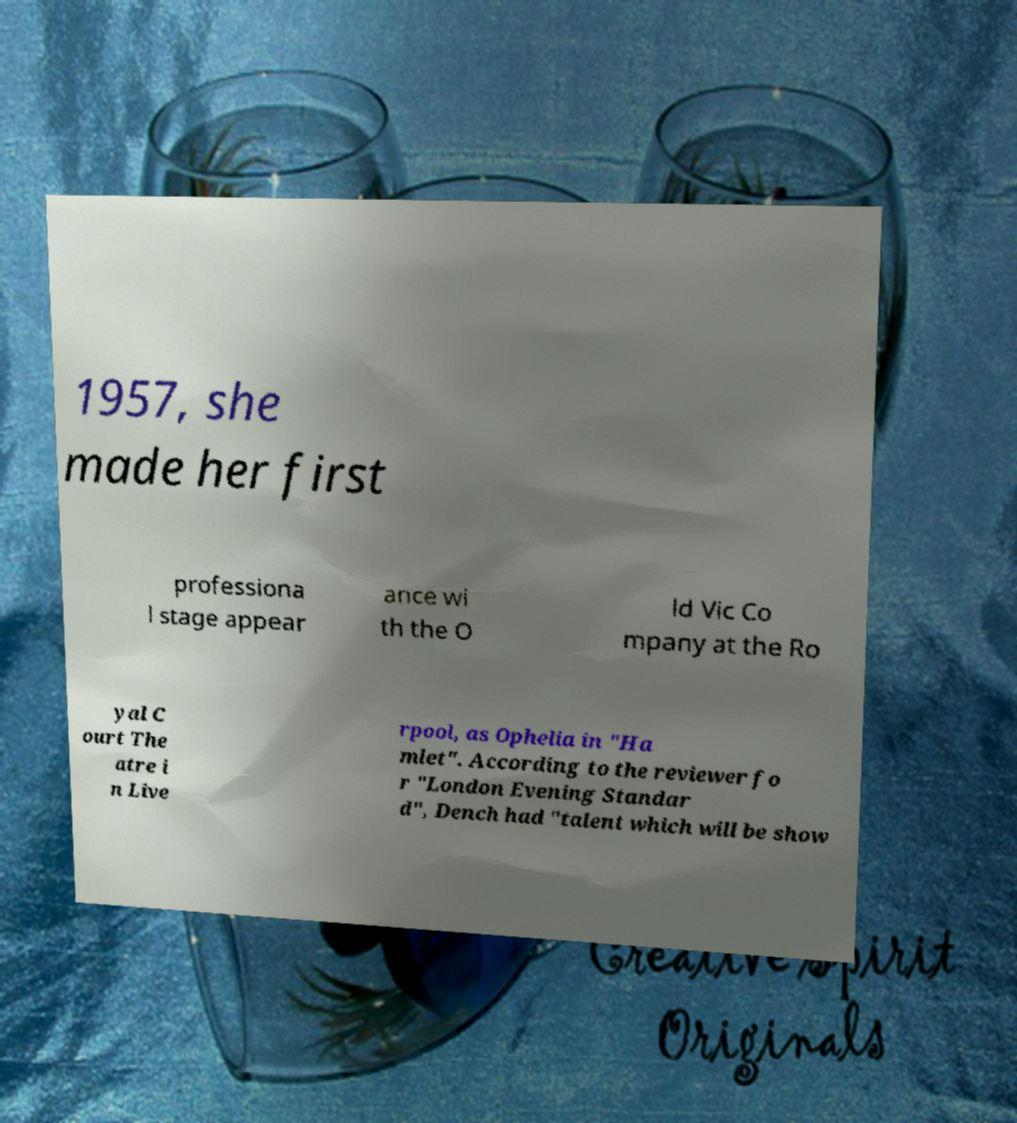Can you accurately transcribe the text from the provided image for me? 1957, she made her first professiona l stage appear ance wi th the O ld Vic Co mpany at the Ro yal C ourt The atre i n Live rpool, as Ophelia in "Ha mlet". According to the reviewer fo r "London Evening Standar d", Dench had "talent which will be show 